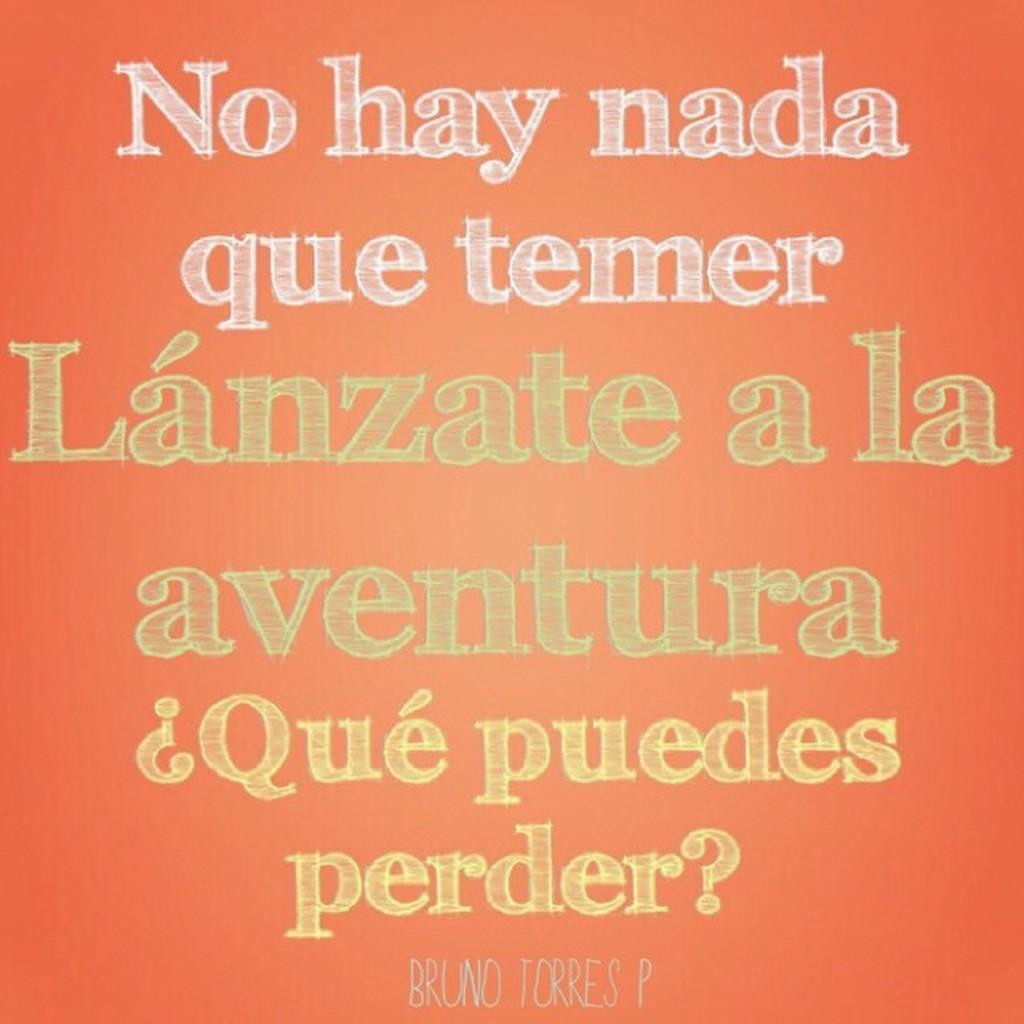What can be found on the image that is related to communication or information? There is text or writing on the image. What color is the background of the image? The background of the image is orange in color. What type of army is depicted in the image? There is no army present in the image; it only features text or writing on an orange background. What language is the text written in? The provided facts do not specify the language of the text, so it cannot be determined from the image. 